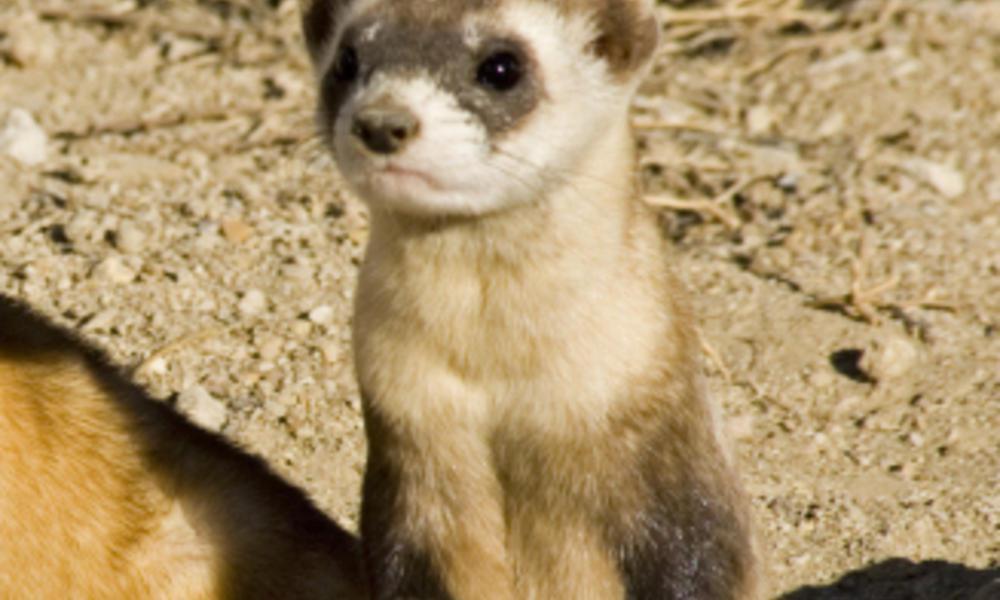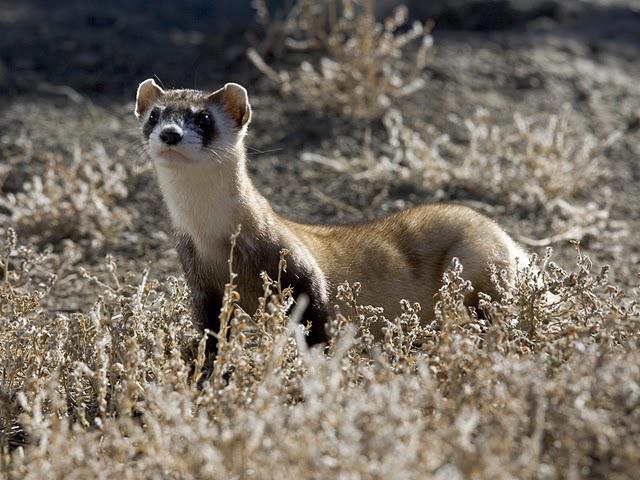The first image is the image on the left, the second image is the image on the right. For the images displayed, is the sentence "There are four ferrets" factually correct? Answer yes or no. No. The first image is the image on the left, the second image is the image on the right. Evaluate the accuracy of this statement regarding the images: "An image shows three ferrets, which are looking forward with heads up.". Is it true? Answer yes or no. No. 